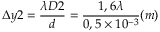Convert formula to latex. <formula><loc_0><loc_0><loc_500><loc_500>\Delta y 2 = \frac { \lambda D 2 } { d } = \frac { 1 , 6 \lambda } { 0 , 5 \times 1 0 ^ { - 3 } } ( m )</formula> 